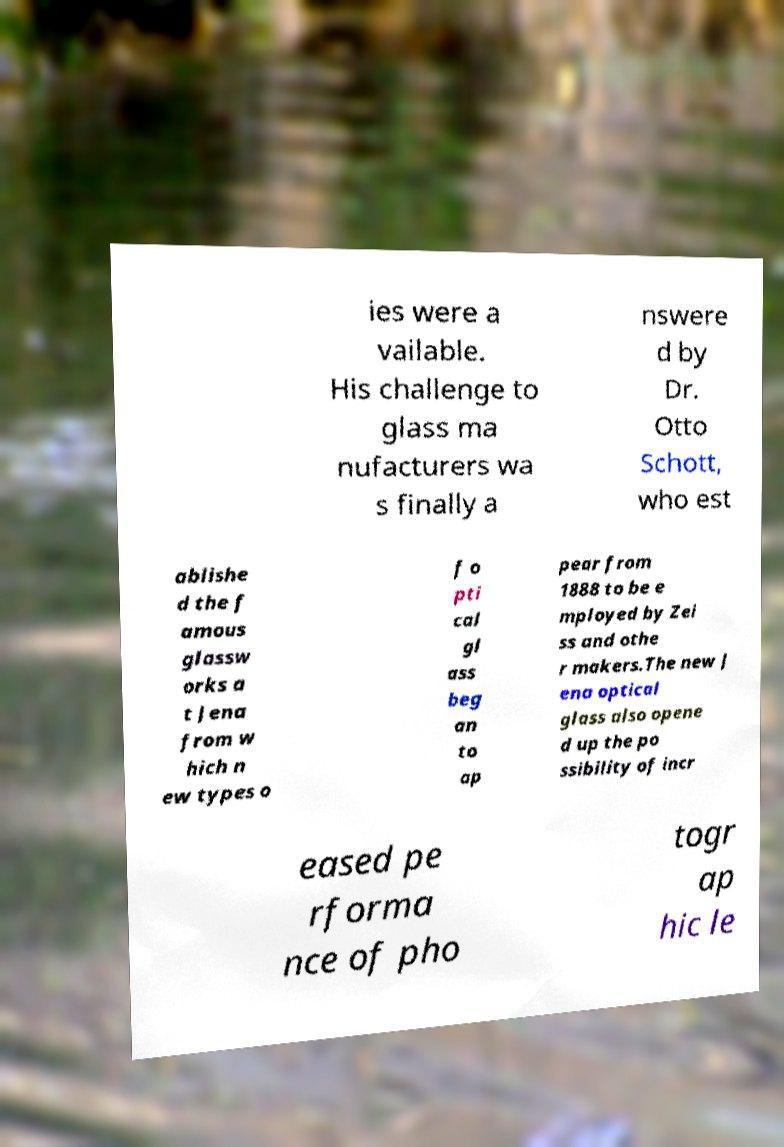Please identify and transcribe the text found in this image. ies were a vailable. His challenge to glass ma nufacturers wa s finally a nswere d by Dr. Otto Schott, who est ablishe d the f amous glassw orks a t Jena from w hich n ew types o f o pti cal gl ass beg an to ap pear from 1888 to be e mployed by Zei ss and othe r makers.The new J ena optical glass also opene d up the po ssibility of incr eased pe rforma nce of pho togr ap hic le 